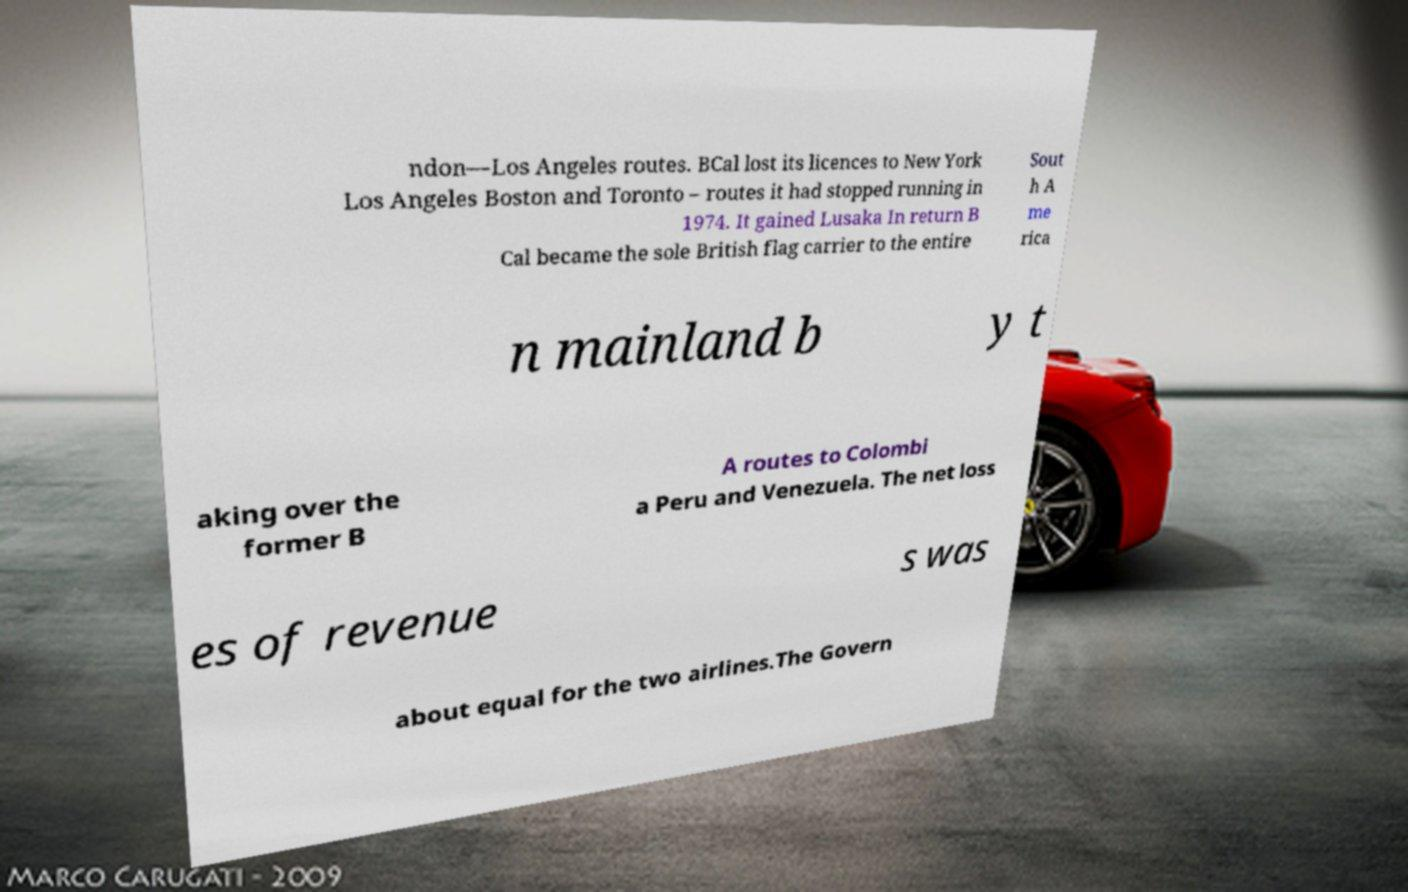For documentation purposes, I need the text within this image transcribed. Could you provide that? ndon—Los Angeles routes. BCal lost its licences to New York Los Angeles Boston and Toronto – routes it had stopped running in 1974. It gained Lusaka In return B Cal became the sole British flag carrier to the entire Sout h A me rica n mainland b y t aking over the former B A routes to Colombi a Peru and Venezuela. The net loss es of revenue s was about equal for the two airlines.The Govern 